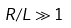<formula> <loc_0><loc_0><loc_500><loc_500>R / L \gg 1</formula> 